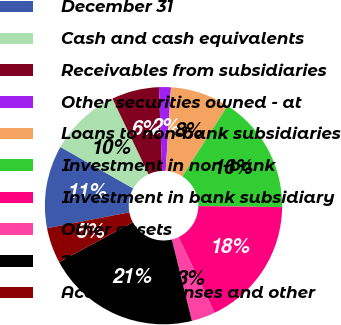<chart> <loc_0><loc_0><loc_500><loc_500><pie_chart><fcel>December 31<fcel>Cash and cash equivalents<fcel>Receivables from subsidiaries<fcel>Other securities owned - at<fcel>Loans to non-bank subsidiaries<fcel>Investment in non-bank<fcel>Investment in bank subsidiary<fcel>Other assets<fcel>Total assets<fcel>Accrued expenses and other<nl><fcel>11.29%<fcel>9.68%<fcel>6.46%<fcel>1.62%<fcel>8.07%<fcel>16.12%<fcel>17.73%<fcel>3.23%<fcel>20.96%<fcel>4.84%<nl></chart> 